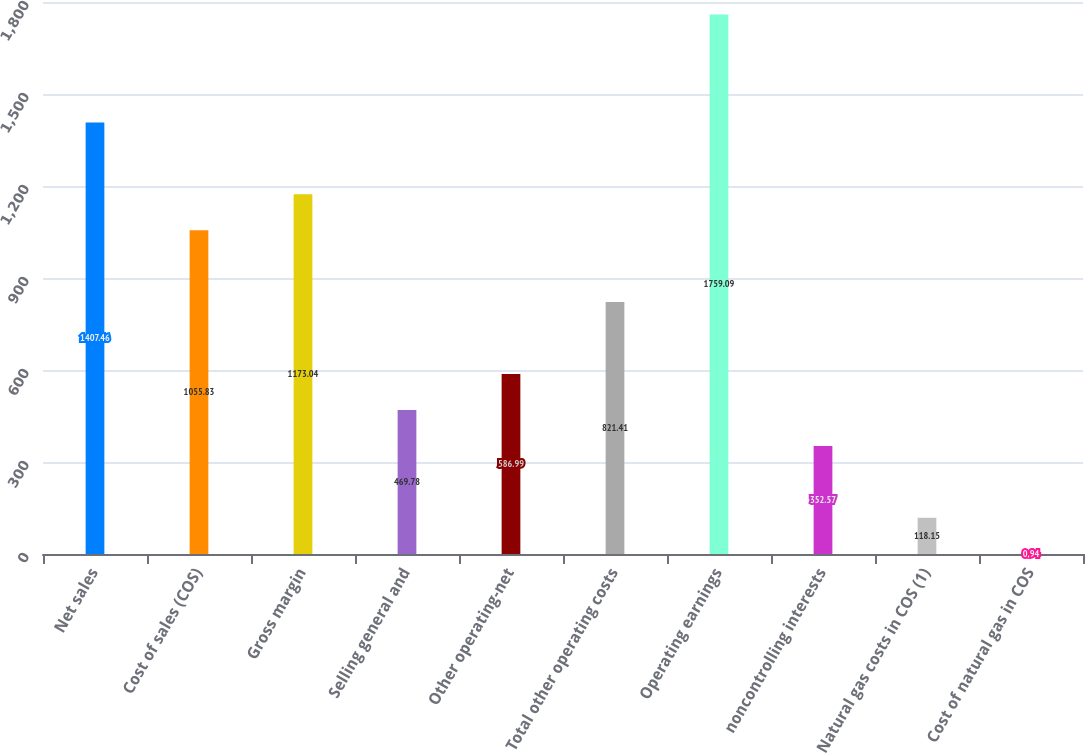<chart> <loc_0><loc_0><loc_500><loc_500><bar_chart><fcel>Net sales<fcel>Cost of sales (COS)<fcel>Gross margin<fcel>Selling general and<fcel>Other operating-net<fcel>Total other operating costs<fcel>Operating earnings<fcel>noncontrolling interests<fcel>Natural gas costs in COS (1)<fcel>Cost of natural gas in COS<nl><fcel>1407.46<fcel>1055.83<fcel>1173.04<fcel>469.78<fcel>586.99<fcel>821.41<fcel>1759.09<fcel>352.57<fcel>118.15<fcel>0.94<nl></chart> 